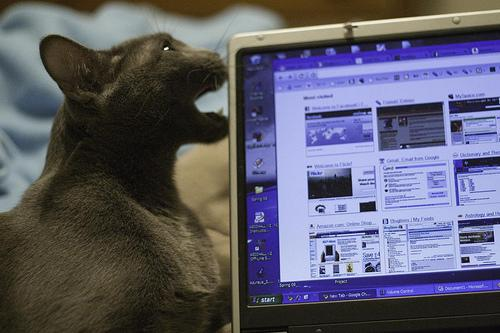Question: what is next to the cat?
Choices:
A. A pillow.
B. A computer.
C. A person.
D. A chair.
Answer with the letter. Answer: B Question: where are the cat's teeth?
Choices:
A. In his mouth.
B. In my arm.
C. In my finger.
D. In his food.
Answer with the letter. Answer: A Question: what is next to the computer?
Choices:
A. A cat.
B. A lamp.
C. A person.
D. A mouse.
Answer with the letter. Answer: A Question: what color do you see behind the cat's head?
Choices:
A. White.
B. Green.
C. Blue.
D. Purple.
Answer with the letter. Answer: C Question: where is the computer?
Choices:
A. On a desk.
B. On the right.
C. In a room.
D. In a house.
Answer with the letter. Answer: B 